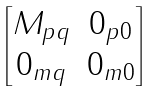Convert formula to latex. <formula><loc_0><loc_0><loc_500><loc_500>\begin{bmatrix} M _ { p q } & 0 _ { p 0 } \\ 0 _ { m q } & 0 _ { m 0 } \end{bmatrix}</formula> 